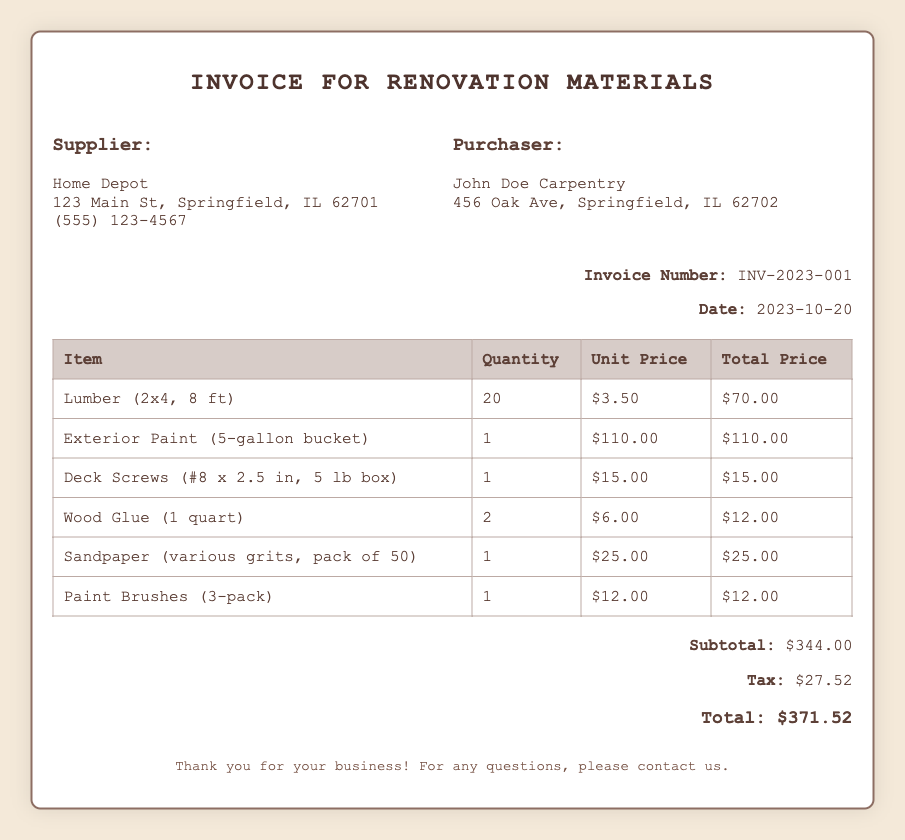What is the supplier's name? The document mentions the supplier as "Home Depot".
Answer: Home Depot What is the invoice number? The invoice number is explicitly stated in the document as "INV-2023-001".
Answer: INV-2023-001 What date was the invoice created? The date of the invoice is provided in the document, which is "2023-10-20".
Answer: 2023-10-20 How many units of lumber were purchased? The document specifies that 20 units of lumber (2x4, 8 ft) were purchased.
Answer: 20 What is the subtotal amount? The subtotal is calculated and presented clearly in the document as "$344.00".
Answer: $344.00 What is the total amount due? The total amount due is calculated and indicated in the document as "$371.52".
Answer: $371.52 What is the quantity of paint purchased? The document states that 1 unit of exterior paint (5-gallon bucket) was purchased.
Answer: 1 Who is the purchaser? The purchaser's name is listed as "John Doe Carpentry".
Answer: John Doe Carpentry What is the tax amount? The tax amounts is specified in the document as "$27.52".
Answer: $27.52 